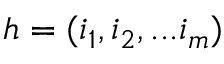Convert formula to latex. <formula><loc_0><loc_0><loc_500><loc_500>h = ( i _ { 1 } , i _ { 2 } , \dots i _ { m } )</formula> 